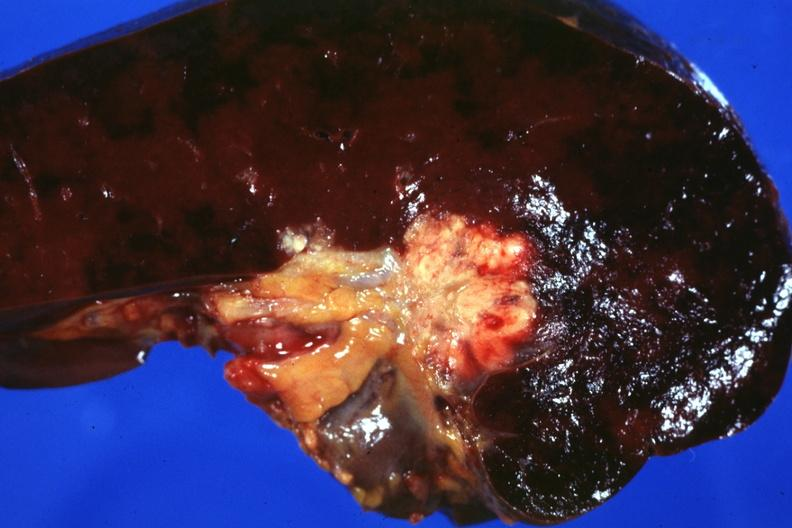what makes one wonder whether node metastases spread into the spleen in this case?
Answer the question using a single word or phrase. This photo 